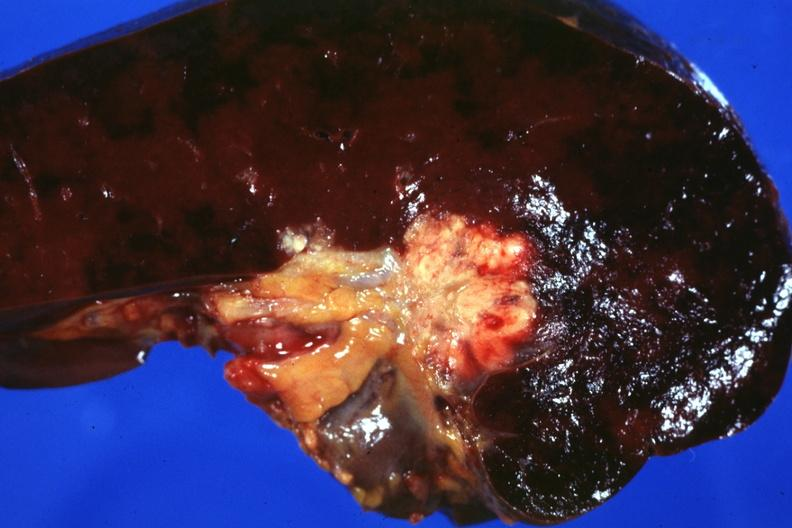what makes one wonder whether node metastases spread into the spleen in this case?
Answer the question using a single word or phrase. This photo 